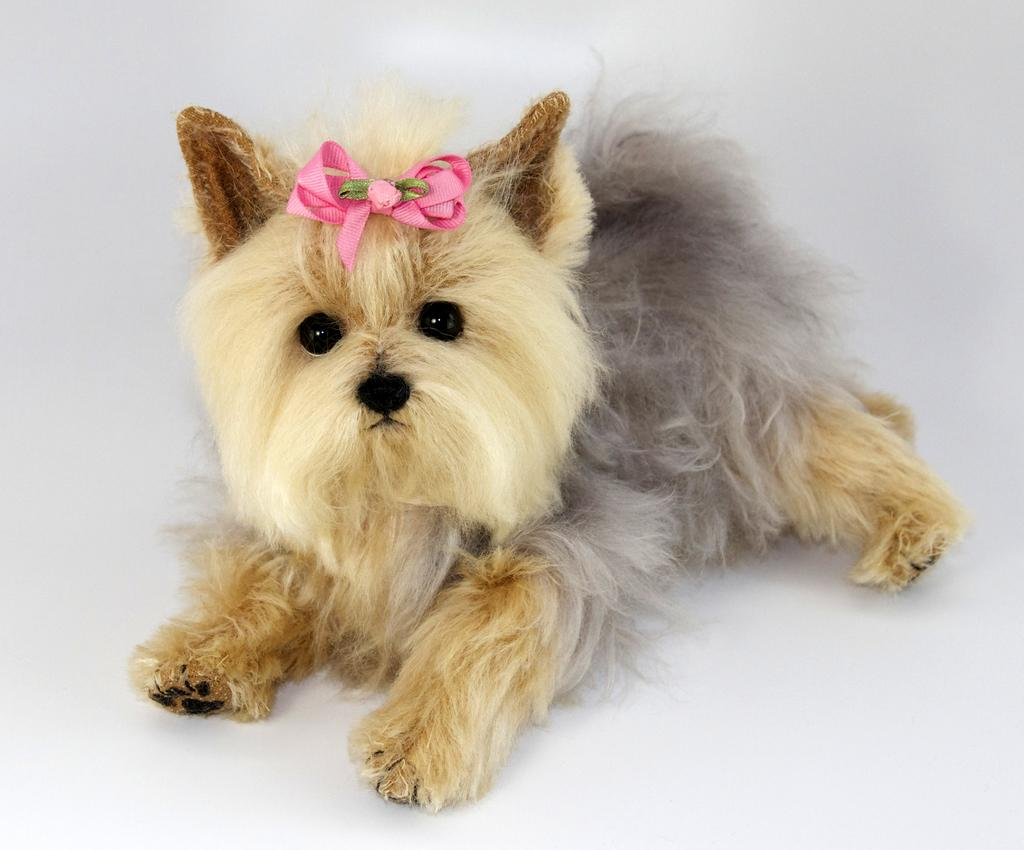What animal is present in the image? There is a dog in the image. Is there anything on the dog's head? Yes, there is an object on the dog's head. What color dominates the image? The remaining portion of the image is in white color. How many marbles can be seen rolling on the dog's back in the image? There are no marbles present in the image, and the dog's back is not visible. 